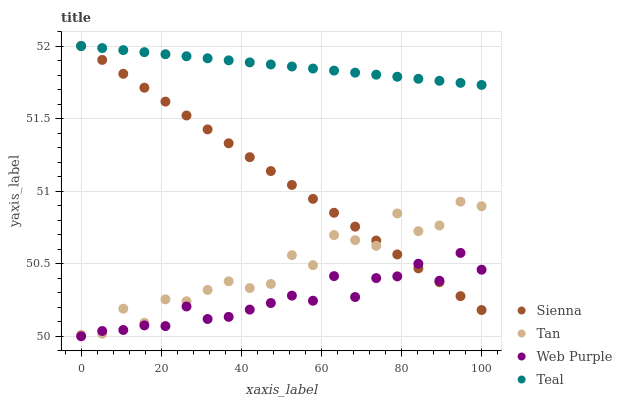Does Web Purple have the minimum area under the curve?
Answer yes or no. Yes. Does Teal have the maximum area under the curve?
Answer yes or no. Yes. Does Tan have the minimum area under the curve?
Answer yes or no. No. Does Tan have the maximum area under the curve?
Answer yes or no. No. Is Sienna the smoothest?
Answer yes or no. Yes. Is Tan the roughest?
Answer yes or no. Yes. Is Web Purple the smoothest?
Answer yes or no. No. Is Web Purple the roughest?
Answer yes or no. No. Does Web Purple have the lowest value?
Answer yes or no. Yes. Does Tan have the lowest value?
Answer yes or no. No. Does Teal have the highest value?
Answer yes or no. Yes. Does Tan have the highest value?
Answer yes or no. No. Is Web Purple less than Teal?
Answer yes or no. Yes. Is Teal greater than Web Purple?
Answer yes or no. Yes. Does Web Purple intersect Tan?
Answer yes or no. Yes. Is Web Purple less than Tan?
Answer yes or no. No. Is Web Purple greater than Tan?
Answer yes or no. No. Does Web Purple intersect Teal?
Answer yes or no. No. 